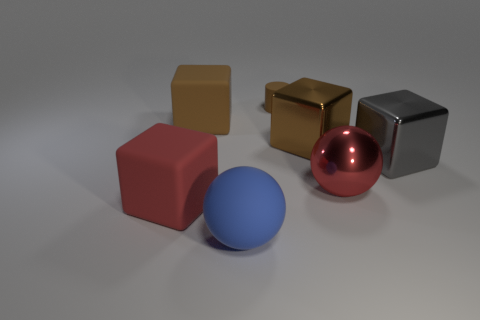Add 1 blue objects. How many objects exist? 8 Subtract all spheres. How many objects are left? 5 Add 5 small purple cylinders. How many small purple cylinders exist? 5 Subtract 0 green cylinders. How many objects are left? 7 Subtract all small red cubes. Subtract all large red things. How many objects are left? 5 Add 6 brown metallic objects. How many brown metallic objects are left? 7 